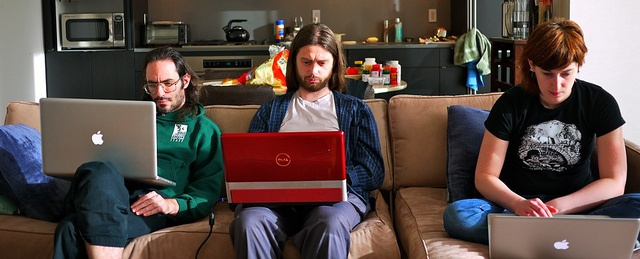Describe the objects in this image and their specific colors. I can see people in gray, black, lightpink, brown, and maroon tones, people in gray, black, teal, darkblue, and lightgray tones, people in gray, black, darkgray, and navy tones, couch in gray, maroon, and black tones, and laptop in gray, black, and darkgray tones in this image. 